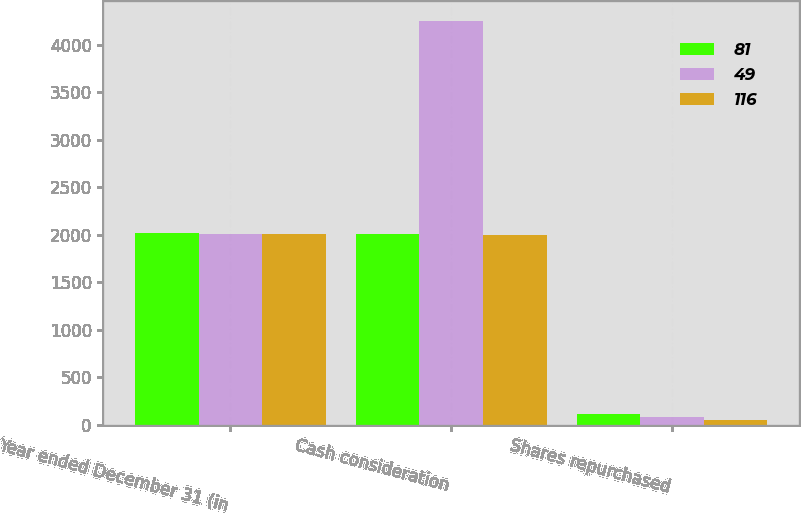<chart> <loc_0><loc_0><loc_500><loc_500><stacked_bar_chart><ecel><fcel>Year ended December 31 (in<fcel>Cash consideration<fcel>Shares repurchased<nl><fcel>81<fcel>2015<fcel>2006.5<fcel>116<nl><fcel>49<fcel>2014<fcel>4251<fcel>81<nl><fcel>116<fcel>2013<fcel>2000<fcel>49<nl></chart> 